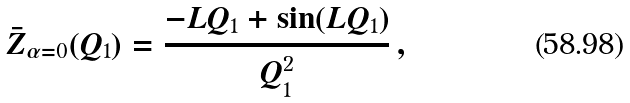Convert formula to latex. <formula><loc_0><loc_0><loc_500><loc_500>\bar { Z } _ { \alpha = 0 } ( Q _ { 1 } ) = \frac { - L Q _ { 1 } + \sin ( L Q _ { 1 } ) } { Q _ { 1 } ^ { 2 } } \, ,</formula> 